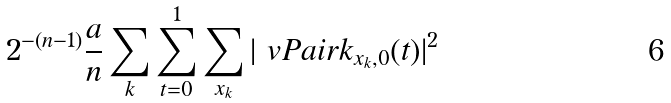<formula> <loc_0><loc_0><loc_500><loc_500>2 ^ { - ( n - 1 ) } \frac { a } { n } \sum _ { k } \sum _ { t = 0 } ^ { 1 } \sum _ { x _ { k } } | \ v P a i r { k } _ { x _ { k } , 0 } ( t ) | ^ { 2 }</formula> 